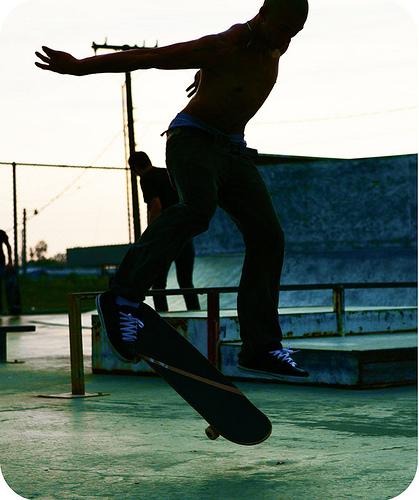Where does this picture take place?
Keep it brief. Skate park. What is this person doing?
Quick response, please. Skateboarding. What time of day is this?
Short answer required. Evening. 